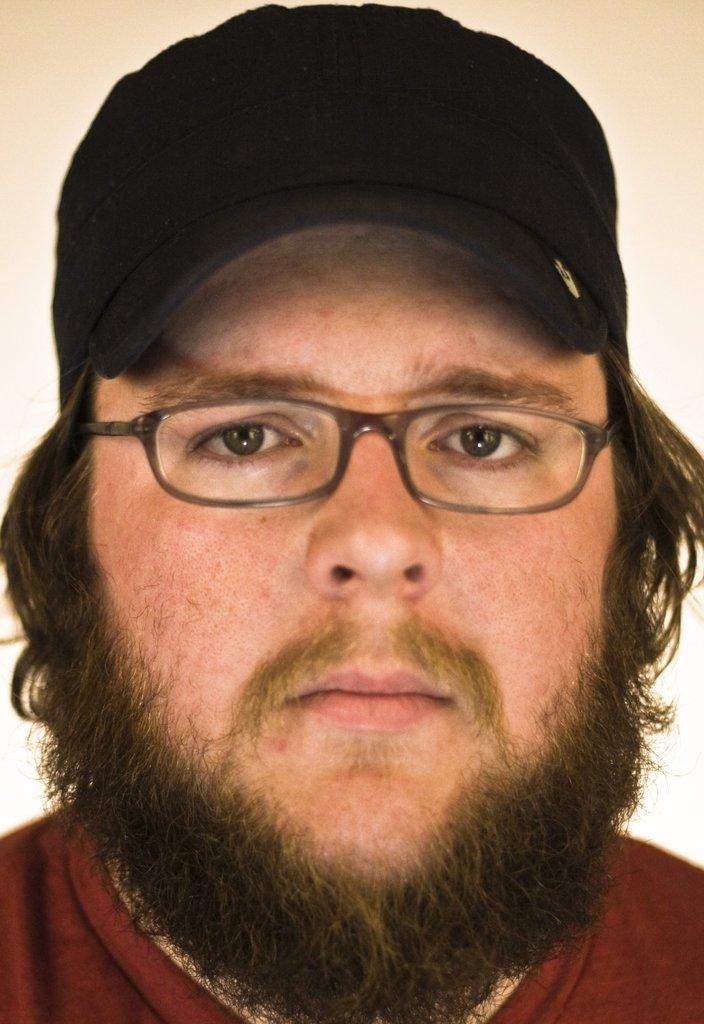What is the main subject of the image? The main subject of the image is a man's head. What is the man wearing on his upper body? The man is wearing a red color T-shirt. What can be seen on the man's head? There is a cap on the man's head. What accessory is the man wearing on his face? The man is wearing spectacles. What type of insurance policy is the man holding in the image? There is no insurance policy present in the image; the man is wearing a cap and spectacles. Can you see any bats flying around the man's head in the image? There are no bats present in the image; it only features the man's head with a cap and spectacles. 